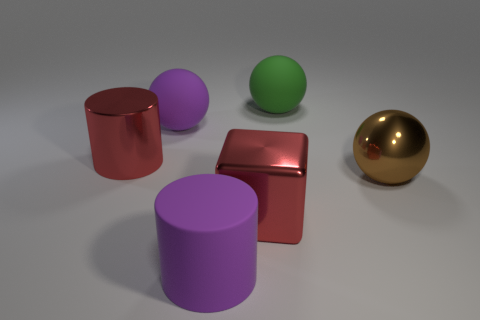Can you identify which objects are more reflective? Certainly, the gold sphere and the cube are more reflective than the other objects. They are both reflecting the environment with a clear shine, indicating their glossy surface. In contrast, the cylinders and the other sphere have more of a diffuse reflection, characteristic of matte surfaces. 